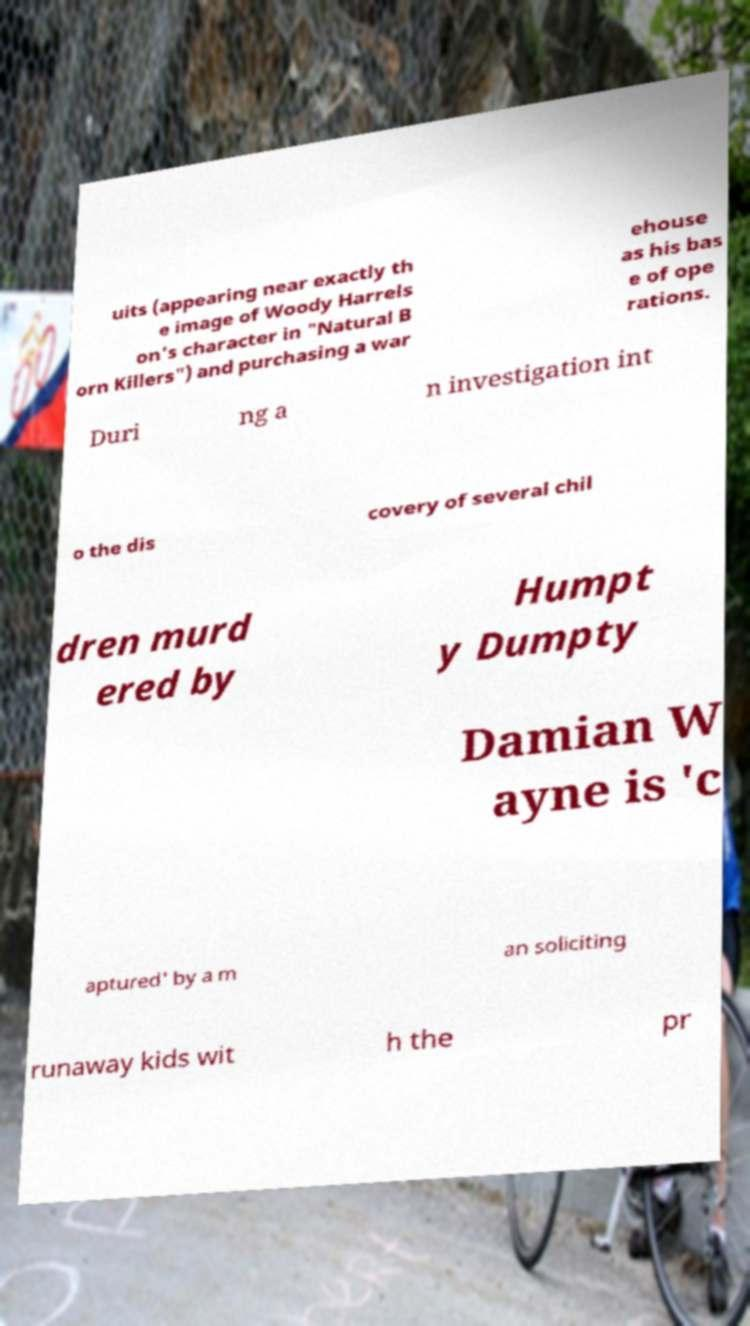What messages or text are displayed in this image? I need them in a readable, typed format. uits (appearing near exactly th e image of Woody Harrels on's character in "Natural B orn Killers") and purchasing a war ehouse as his bas e of ope rations. Duri ng a n investigation int o the dis covery of several chil dren murd ered by Humpt y Dumpty Damian W ayne is 'c aptured' by a m an soliciting runaway kids wit h the pr 